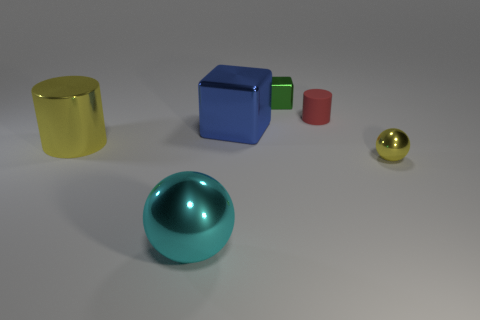There is a yellow metallic cylinder; is it the same size as the shiny ball that is right of the matte object?
Your answer should be very brief. No. There is a ball that is the same color as the large shiny cylinder; what is it made of?
Give a very brief answer. Metal. What is the size of the cylinder that is to the right of the small metallic thing that is to the left of the sphere that is on the right side of the big blue metallic cube?
Keep it short and to the point. Small. Are there more red rubber cylinders in front of the tiny cube than green shiny blocks behind the large ball?
Your answer should be very brief. No. How many big objects are behind the yellow shiny object on the left side of the green object?
Your answer should be very brief. 1. Is there a small metallic sphere that has the same color as the tiny matte object?
Provide a short and direct response. No. Do the red rubber cylinder and the blue cube have the same size?
Ensure brevity in your answer.  No. Is the color of the tiny sphere the same as the large cylinder?
Offer a very short reply. Yes. What material is the yellow object to the right of the cylinder that is behind the big block?
Ensure brevity in your answer.  Metal. There is a red object that is the same shape as the large yellow thing; what is its material?
Ensure brevity in your answer.  Rubber. 